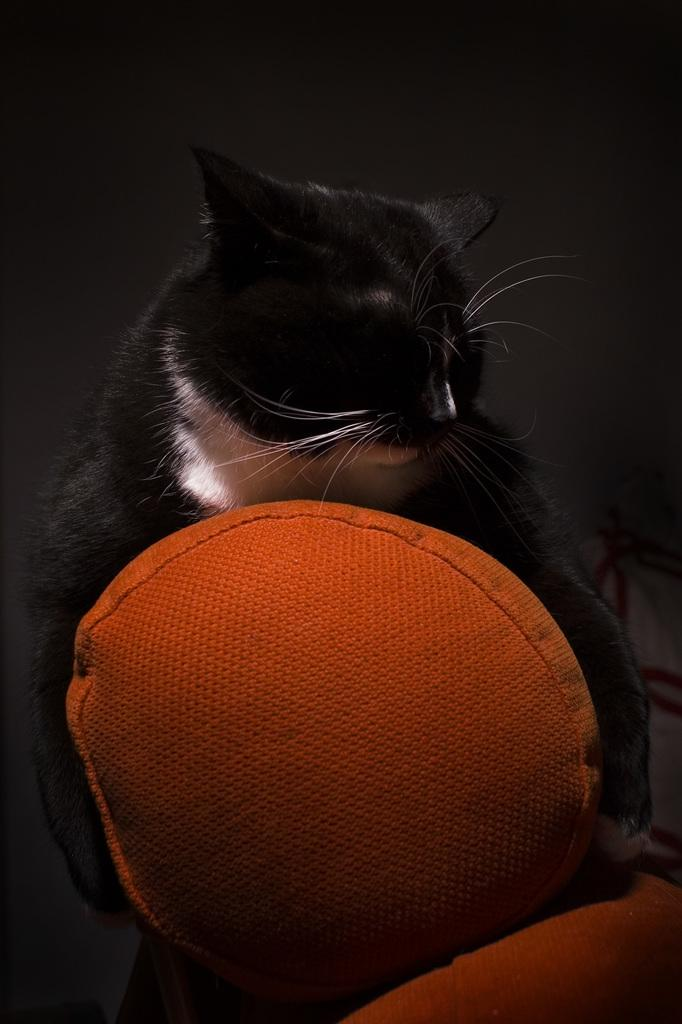What animal is present in the image? There is a cat in the image. What is the cat holding in its paws? The cat is holding a ball. What type of cloth is being used to tell a story in the image? There is no cloth or storytelling activity present in the image; it features a cat holding a ball. 